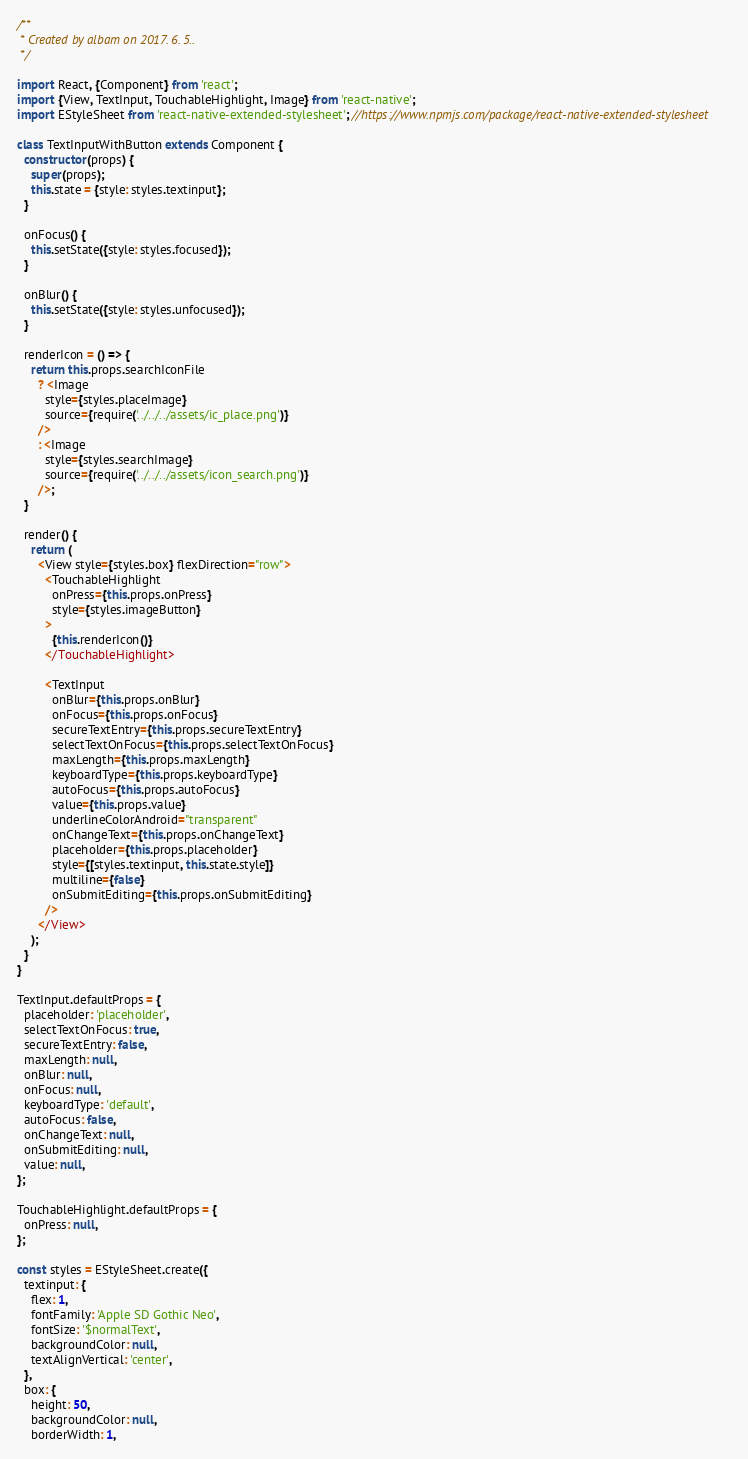<code> <loc_0><loc_0><loc_500><loc_500><_JavaScript_>/**
 * Created by albam on 2017. 6. 5..
 */

import React, {Component} from 'react';
import {View, TextInput, TouchableHighlight, Image} from 'react-native';
import EStyleSheet from 'react-native-extended-stylesheet'; //https://www.npmjs.com/package/react-native-extended-stylesheet

class TextInputWithButton extends Component {
  constructor(props) {
    super(props);
    this.state = {style: styles.textinput};
  }

  onFocus() {
    this.setState({style: styles.focused});
  }

  onBlur() {
    this.setState({style: styles.unfocused});
  }

  renderIcon = () => {
    return this.props.searchIconFile
      ? <Image
        style={styles.placeImage}
        source={require('../../../assets/ic_place.png')}
      />
      : <Image
        style={styles.searchImage}
        source={require('../../../assets/icon_search.png')}
      />;
  }

  render() {
    return (
      <View style={styles.box} flexDirection="row">
        <TouchableHighlight
          onPress={this.props.onPress}
          style={styles.imageButton}
        >
          {this.renderIcon()}
        </TouchableHighlight>

        <TextInput
          onBlur={this.props.onBlur}
          onFocus={this.props.onFocus}
          secureTextEntry={this.props.secureTextEntry}
          selectTextOnFocus={this.props.selectTextOnFocus}
          maxLength={this.props.maxLength}
          keyboardType={this.props.keyboardType}
          autoFocus={this.props.autoFocus}
          value={this.props.value}
          underlineColorAndroid="transparent"
          onChangeText={this.props.onChangeText}
          placeholder={this.props.placeholder}
          style={[styles.textinput, this.state.style]}
          multiline={false}
          onSubmitEditing={this.props.onSubmitEditing}
        />
      </View>
    );
  }
}

TextInput.defaultProps = {
  placeholder: 'placeholder',
  selectTextOnFocus: true,
  secureTextEntry: false,
  maxLength: null,
  onBlur: null,
  onFocus: null,
  keyboardType: 'default',
  autoFocus: false,
  onChangeText: null,
  onSubmitEditing: null,
  value: null,
};

TouchableHighlight.defaultProps = {
  onPress: null,
};

const styles = EStyleSheet.create({
  textinput: {
    flex: 1,
    fontFamily: 'Apple SD Gothic Neo',
    fontSize: '$normalText',
    backgroundColor: null,
    textAlignVertical: 'center',
  },
  box: {
    height: 50,
    backgroundColor: null,
    borderWidth: 1,</code> 